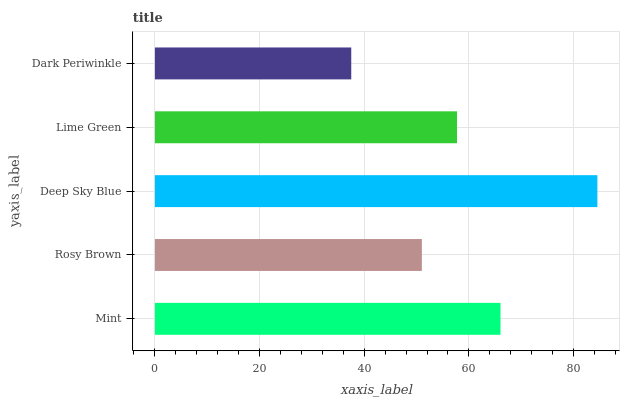Is Dark Periwinkle the minimum?
Answer yes or no. Yes. Is Deep Sky Blue the maximum?
Answer yes or no. Yes. Is Rosy Brown the minimum?
Answer yes or no. No. Is Rosy Brown the maximum?
Answer yes or no. No. Is Mint greater than Rosy Brown?
Answer yes or no. Yes. Is Rosy Brown less than Mint?
Answer yes or no. Yes. Is Rosy Brown greater than Mint?
Answer yes or no. No. Is Mint less than Rosy Brown?
Answer yes or no. No. Is Lime Green the high median?
Answer yes or no. Yes. Is Lime Green the low median?
Answer yes or no. Yes. Is Dark Periwinkle the high median?
Answer yes or no. No. Is Deep Sky Blue the low median?
Answer yes or no. No. 